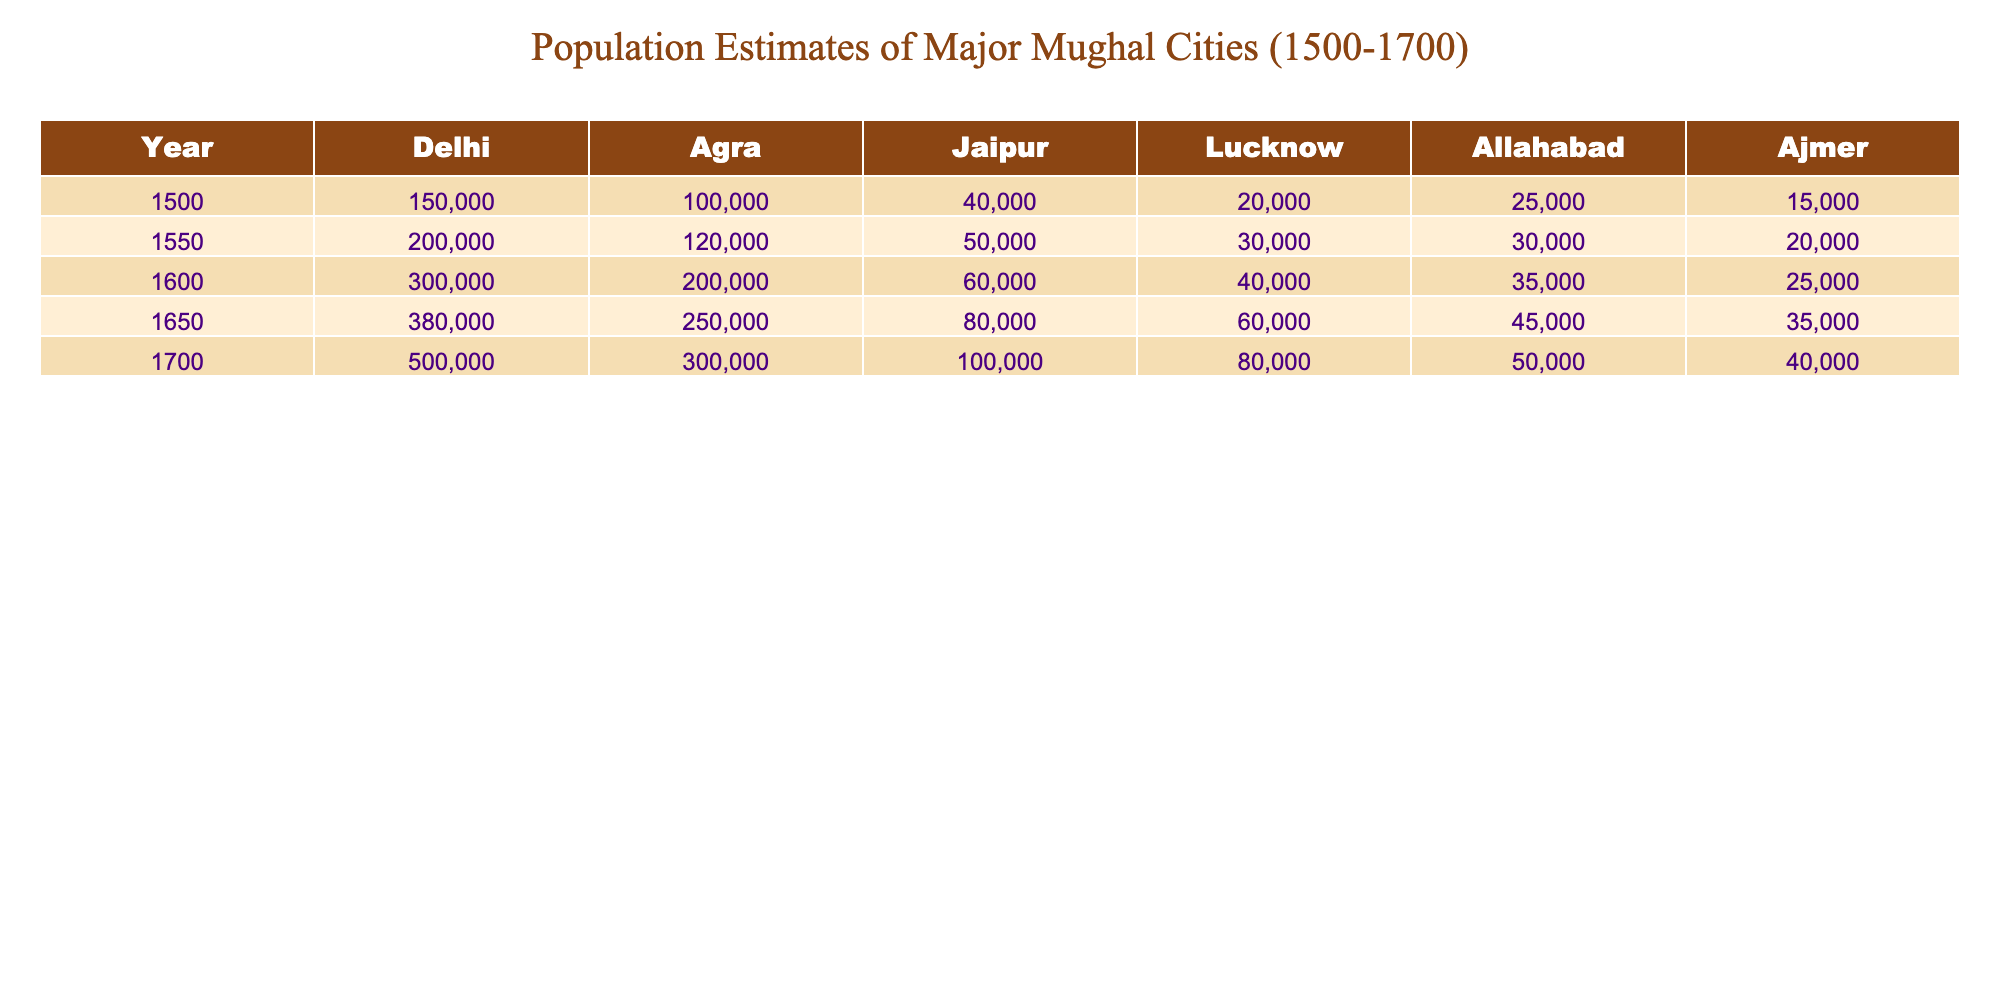What was the population of Delhi in 1600? The table indicates that the population of Delhi in 1600 is directly provided as 300,000.
Answer: 300,000 Which city had the lowest population estimate in 1500? By examining the first row of the table under "1500," Ajmer has the lowest population estimate of 15,000 compared to other cities.
Answer: Ajmer What is the difference in population between Agra in 1700 and Allahabad in 1650? The population of Agra in 1700 is 300,000, while the population of Allahabad in 1650 is 45,000. The difference is calculated as 300,000 - 45,000 = 255,000.
Answer: 255,000 What was the average population of Jaipur from 1500 to 1700? To find the average population of Jaipur, first sum the populations: 40,000 + 50,000 + 60,000 + 80,000 + 100,000 = 330,000. There are 5 data points (years), so the average is 330,000 / 5 = 66,000.
Answer: 66,000 Did the population of Lucknow exceed 50,000 in any of the recorded years? The values for Lucknow across all years are 20,000, 30,000, 40,000, 60,000, and 80,000, which shows that in 1650 (60,000) and 1700 (80,000), the population indeed exceeded 50,000. Thus, the answer is yes.
Answer: Yes Which city had the largest increase in population between 1500 and 1700? To find the city with the largest increase, I look at the populations in 1500 and 1700: Delhi increased from 150,000 to 500,000 (350,000 increase), Agra from 100,000 to 300,000 (200,000 increase), Jaipur from 40,000 to 100,000 (60,000 increase), Lucknow from 20,000 to 80,000 (60,000 increase), Allahabad from 25,000 to 50,000 (25,000 increase), and Ajmer from 15,000 to 40,000 (25,000 increase). The maximum increase is in Delhi (350,000).
Answer: Delhi In which year did Agra have a population close to 200,000? Looking through the table, the year closest to 200,000 for Agra is 1600, where the population is exactly 200,000.
Answer: 1600 How many cities had a population of over 100,000 in 1700? In 1700, the cities with populations over 100,000 are Delhi (500,000), Agra (300,000), and Jaipur (100,000), making a total of three cities.
Answer: 3 